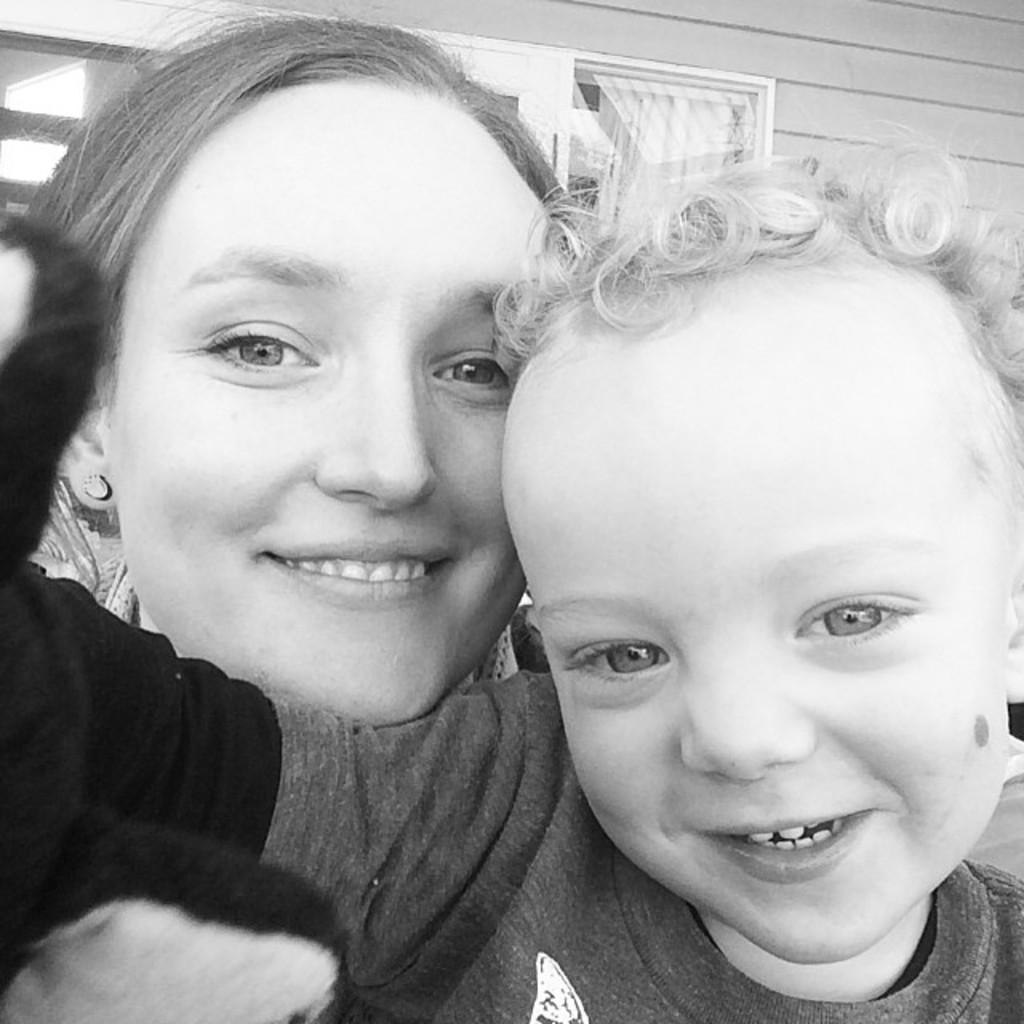In one or two sentences, can you explain what this image depicts? In this picture we can see a boy and a woman smiling. There is a building in the background. 